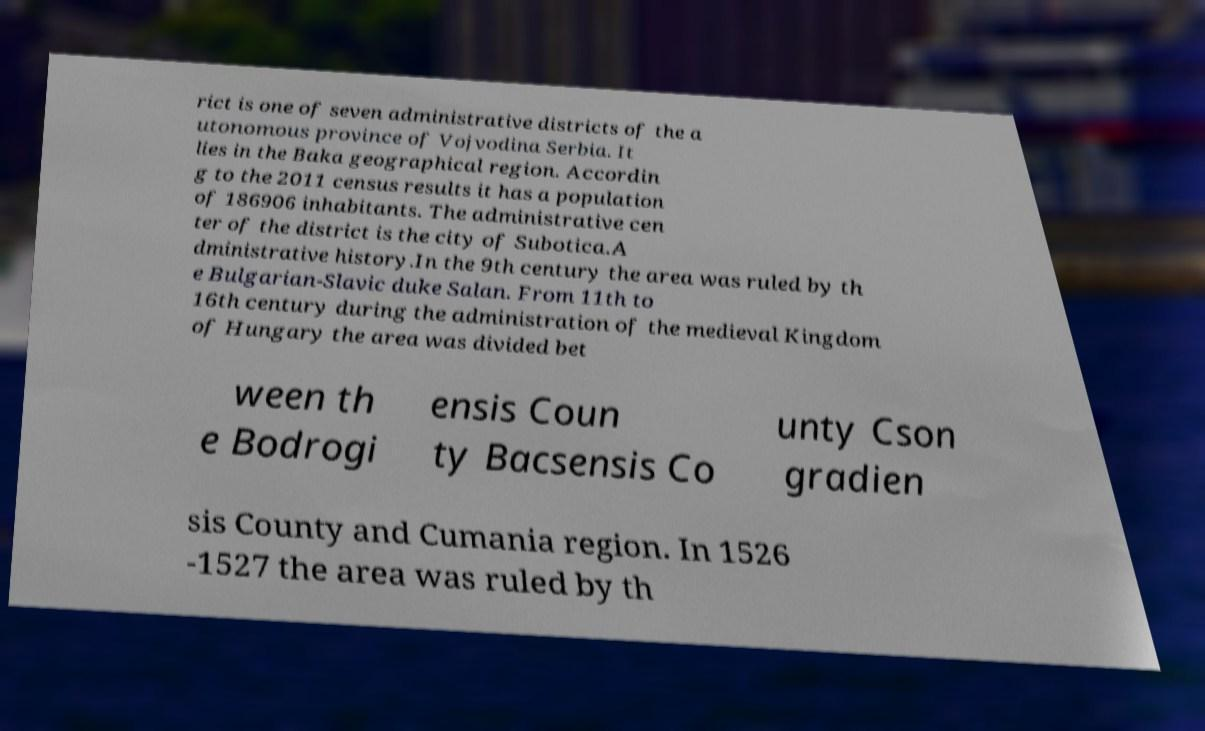Could you extract and type out the text from this image? rict is one of seven administrative districts of the a utonomous province of Vojvodina Serbia. It lies in the Baka geographical region. Accordin g to the 2011 census results it has a population of 186906 inhabitants. The administrative cen ter of the district is the city of Subotica.A dministrative history.In the 9th century the area was ruled by th e Bulgarian-Slavic duke Salan. From 11th to 16th century during the administration of the medieval Kingdom of Hungary the area was divided bet ween th e Bodrogi ensis Coun ty Bacsensis Co unty Cson gradien sis County and Cumania region. In 1526 -1527 the area was ruled by th 